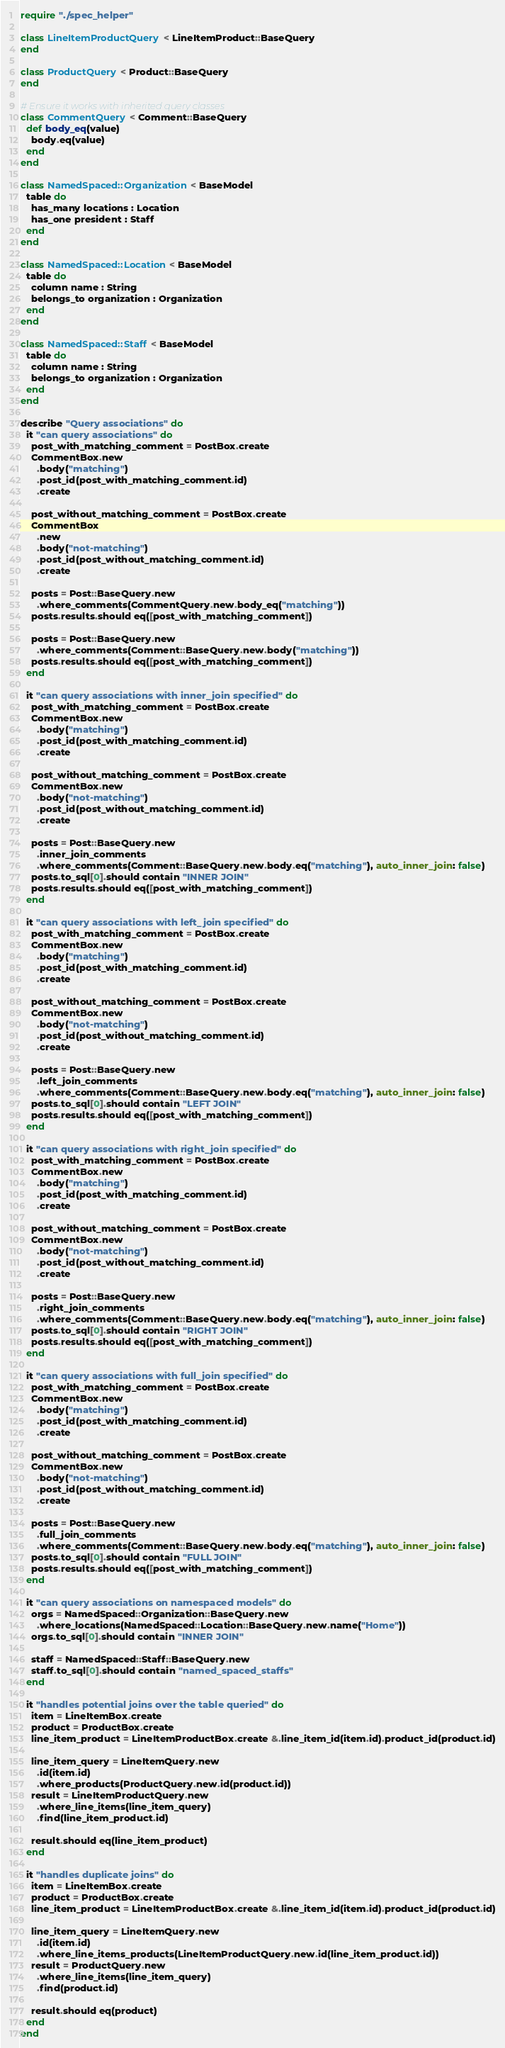<code> <loc_0><loc_0><loc_500><loc_500><_Crystal_>require "./spec_helper"

class LineItemProductQuery < LineItemProduct::BaseQuery
end

class ProductQuery < Product::BaseQuery
end

# Ensure it works with inherited query classes
class CommentQuery < Comment::BaseQuery
  def body_eq(value)
    body.eq(value)
  end
end

class NamedSpaced::Organization < BaseModel
  table do
    has_many locations : Location
    has_one president : Staff
  end
end

class NamedSpaced::Location < BaseModel
  table do
    column name : String
    belongs_to organization : Organization
  end
end

class NamedSpaced::Staff < BaseModel
  table do
    column name : String
    belongs_to organization : Organization
  end
end

describe "Query associations" do
  it "can query associations" do
    post_with_matching_comment = PostBox.create
    CommentBox.new
      .body("matching")
      .post_id(post_with_matching_comment.id)
      .create

    post_without_matching_comment = PostBox.create
    CommentBox
      .new
      .body("not-matching")
      .post_id(post_without_matching_comment.id)
      .create

    posts = Post::BaseQuery.new
      .where_comments(CommentQuery.new.body_eq("matching"))
    posts.results.should eq([post_with_matching_comment])

    posts = Post::BaseQuery.new
      .where_comments(Comment::BaseQuery.new.body("matching"))
    posts.results.should eq([post_with_matching_comment])
  end

  it "can query associations with inner_join specified" do
    post_with_matching_comment = PostBox.create
    CommentBox.new
      .body("matching")
      .post_id(post_with_matching_comment.id)
      .create

    post_without_matching_comment = PostBox.create
    CommentBox.new
      .body("not-matching")
      .post_id(post_without_matching_comment.id)
      .create

    posts = Post::BaseQuery.new
      .inner_join_comments
      .where_comments(Comment::BaseQuery.new.body.eq("matching"), auto_inner_join: false)
    posts.to_sql[0].should contain "INNER JOIN"
    posts.results.should eq([post_with_matching_comment])
  end

  it "can query associations with left_join specified" do
    post_with_matching_comment = PostBox.create
    CommentBox.new
      .body("matching")
      .post_id(post_with_matching_comment.id)
      .create

    post_without_matching_comment = PostBox.create
    CommentBox.new
      .body("not-matching")
      .post_id(post_without_matching_comment.id)
      .create

    posts = Post::BaseQuery.new
      .left_join_comments
      .where_comments(Comment::BaseQuery.new.body.eq("matching"), auto_inner_join: false)
    posts.to_sql[0].should contain "LEFT JOIN"
    posts.results.should eq([post_with_matching_comment])
  end

  it "can query associations with right_join specified" do
    post_with_matching_comment = PostBox.create
    CommentBox.new
      .body("matching")
      .post_id(post_with_matching_comment.id)
      .create

    post_without_matching_comment = PostBox.create
    CommentBox.new
      .body("not-matching")
      .post_id(post_without_matching_comment.id)
      .create

    posts = Post::BaseQuery.new
      .right_join_comments
      .where_comments(Comment::BaseQuery.new.body.eq("matching"), auto_inner_join: false)
    posts.to_sql[0].should contain "RIGHT JOIN"
    posts.results.should eq([post_with_matching_comment])
  end

  it "can query associations with full_join specified" do
    post_with_matching_comment = PostBox.create
    CommentBox.new
      .body("matching")
      .post_id(post_with_matching_comment.id)
      .create

    post_without_matching_comment = PostBox.create
    CommentBox.new
      .body("not-matching")
      .post_id(post_without_matching_comment.id)
      .create

    posts = Post::BaseQuery.new
      .full_join_comments
      .where_comments(Comment::BaseQuery.new.body.eq("matching"), auto_inner_join: false)
    posts.to_sql[0].should contain "FULL JOIN"
    posts.results.should eq([post_with_matching_comment])
  end

  it "can query associations on namespaced models" do
    orgs = NamedSpaced::Organization::BaseQuery.new
      .where_locations(NamedSpaced::Location::BaseQuery.new.name("Home"))
    orgs.to_sql[0].should contain "INNER JOIN"

    staff = NamedSpaced::Staff::BaseQuery.new
    staff.to_sql[0].should contain "named_spaced_staffs"
  end

  it "handles potential joins over the table queried" do
    item = LineItemBox.create
    product = ProductBox.create
    line_item_product = LineItemProductBox.create &.line_item_id(item.id).product_id(product.id)

    line_item_query = LineItemQuery.new
      .id(item.id)
      .where_products(ProductQuery.new.id(product.id))
    result = LineItemProductQuery.new
      .where_line_items(line_item_query)
      .find(line_item_product.id)

    result.should eq(line_item_product)
  end

  it "handles duplicate joins" do
    item = LineItemBox.create
    product = ProductBox.create
    line_item_product = LineItemProductBox.create &.line_item_id(item.id).product_id(product.id)

    line_item_query = LineItemQuery.new
      .id(item.id)
      .where_line_items_products(LineItemProductQuery.new.id(line_item_product.id))
    result = ProductQuery.new
      .where_line_items(line_item_query)
      .find(product.id)

    result.should eq(product)
  end
end
</code> 